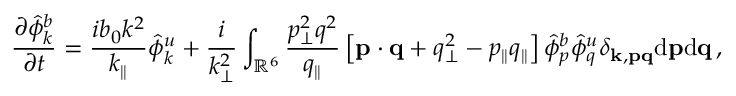<formula> <loc_0><loc_0><loc_500><loc_500>{ \frac { \partial \hat { \phi } _ { k } ^ { b } } { \partial t } } = \frac { i b _ { 0 } k ^ { 2 } } { k _ { \| } } \hat { \phi } _ { k } ^ { u } + \frac { i } { k _ { \perp } ^ { 2 } } \int _ { \mathbb { R } ^ { 6 } } \frac { p _ { \perp } ^ { 2 } q ^ { 2 } } { q _ { \| } } \left [ { p } \cdot { q } + q _ { \perp } ^ { 2 } - p _ { \| } q _ { \| } \right ] \hat { \phi } _ { p } ^ { b } \hat { \phi } _ { q } ^ { u } \delta _ { { k } , { p } { q } } d { p } d { q } \, ,</formula> 